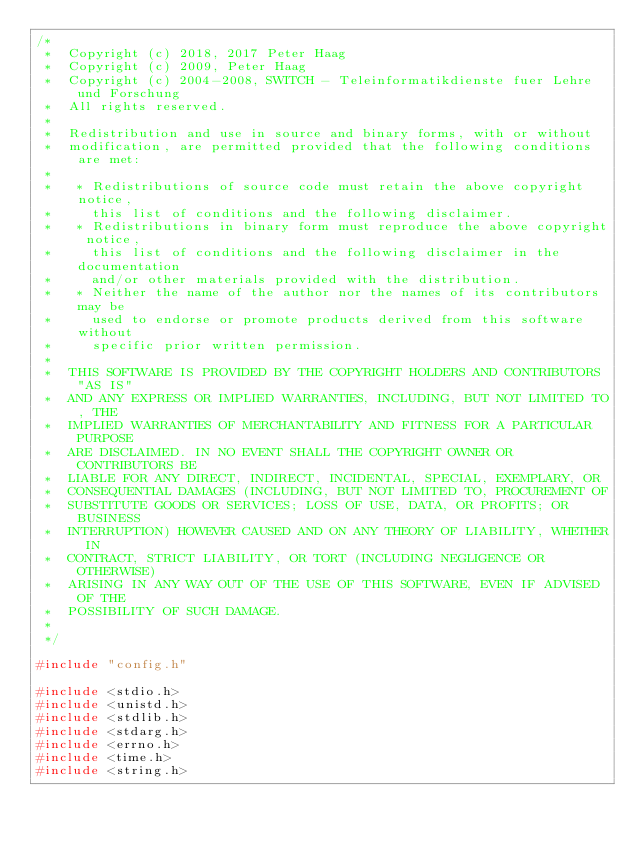Convert code to text. <code><loc_0><loc_0><loc_500><loc_500><_C_>/*
 *  Copyright (c) 2018, 2017 Peter Haag
 *  Copyright (c) 2009, Peter Haag
 *  Copyright (c) 2004-2008, SWITCH - Teleinformatikdienste fuer Lehre und Forschung
 *  All rights reserved.
 *  
 *  Redistribution and use in source and binary forms, with or without 
 *  modification, are permitted provided that the following conditions are met:
 *  
 *   * Redistributions of source code must retain the above copyright notice, 
 *     this list of conditions and the following disclaimer.
 *   * Redistributions in binary form must reproduce the above copyright notice, 
 *     this list of conditions and the following disclaimer in the documentation 
 *     and/or other materials provided with the distribution.
 *   * Neither the name of the author nor the names of its contributors may be 
 *     used to endorse or promote products derived from this software without 
 *     specific prior written permission.
 *  
 *  THIS SOFTWARE IS PROVIDED BY THE COPYRIGHT HOLDERS AND CONTRIBUTORS "AS IS" 
 *  AND ANY EXPRESS OR IMPLIED WARRANTIES, INCLUDING, BUT NOT LIMITED TO, THE 
 *  IMPLIED WARRANTIES OF MERCHANTABILITY AND FITNESS FOR A PARTICULAR PURPOSE 
 *  ARE DISCLAIMED. IN NO EVENT SHALL THE COPYRIGHT OWNER OR CONTRIBUTORS BE 
 *  LIABLE FOR ANY DIRECT, INDIRECT, INCIDENTAL, SPECIAL, EXEMPLARY, OR 
 *  CONSEQUENTIAL DAMAGES (INCLUDING, BUT NOT LIMITED TO, PROCUREMENT OF 
 *  SUBSTITUTE GOODS OR SERVICES; LOSS OF USE, DATA, OR PROFITS; OR BUSINESS 
 *  INTERRUPTION) HOWEVER CAUSED AND ON ANY THEORY OF LIABILITY, WHETHER IN 
 *  CONTRACT, STRICT LIABILITY, OR TORT (INCLUDING NEGLIGENCE OR OTHERWISE) 
 *  ARISING IN ANY WAY OUT OF THE USE OF THIS SOFTWARE, EVEN IF ADVISED OF THE 
 *  POSSIBILITY OF SUCH DAMAGE.
 *  
 */

#include "config.h"

#include <stdio.h>
#include <unistd.h>
#include <stdlib.h>
#include <stdarg.h>
#include <errno.h>
#include <time.h>
#include <string.h></code> 